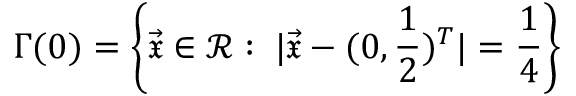<formula> <loc_0><loc_0><loc_500><loc_500>\Gamma ( 0 ) = \left \{ \vec { \mathfrak { x } } \in \ m a t h s c r { R } \colon \, | \vec { \mathfrak { x } } - ( 0 , \frac { 1 } { 2 } ) ^ { T } | = \frac { 1 } { 4 } \right \}</formula> 